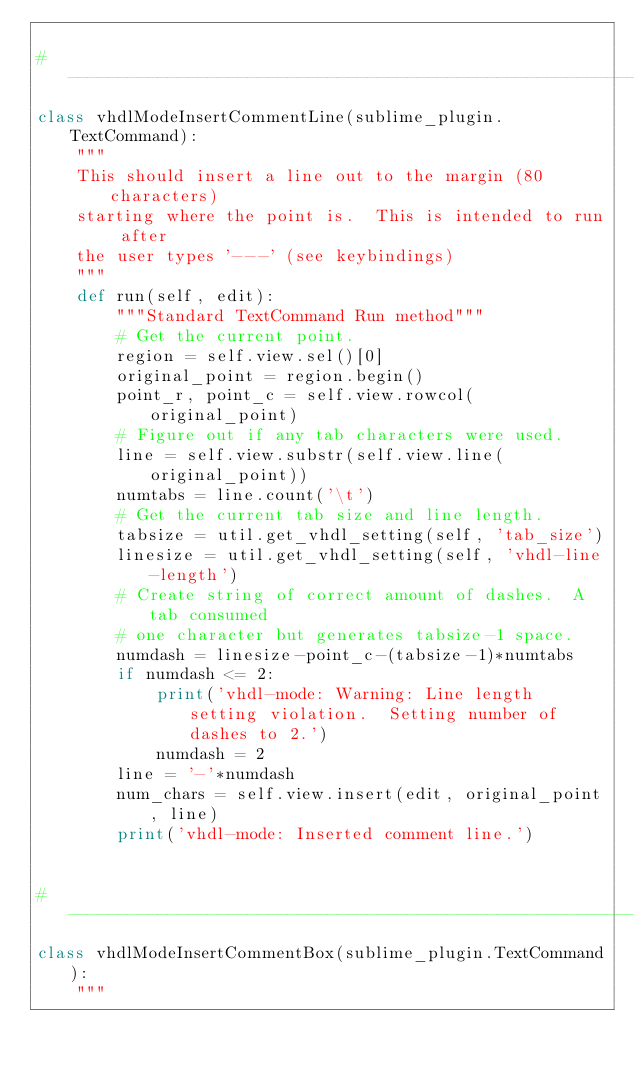<code> <loc_0><loc_0><loc_500><loc_500><_Python_>
#-------------------------------------------------------------------------------
class vhdlModeInsertCommentLine(sublime_plugin.TextCommand):
    """
    This should insert a line out to the margin (80 characters)
    starting where the point is.  This is intended to run after
    the user types '---' (see keybindings)
    """
    def run(self, edit):
        """Standard TextCommand Run method"""
        # Get the current point.
        region = self.view.sel()[0]
        original_point = region.begin()
        point_r, point_c = self.view.rowcol(original_point)
        # Figure out if any tab characters were used.
        line = self.view.substr(self.view.line(original_point))
        numtabs = line.count('\t')
        # Get the current tab size and line length.
        tabsize = util.get_vhdl_setting(self, 'tab_size')
        linesize = util.get_vhdl_setting(self, 'vhdl-line-length')
        # Create string of correct amount of dashes.  A tab consumed
        # one character but generates tabsize-1 space.
        numdash = linesize-point_c-(tabsize-1)*numtabs
        if numdash <= 2:
            print('vhdl-mode: Warning: Line length setting violation.  Setting number of dashes to 2.')
            numdash = 2
        line = '-'*numdash
        num_chars = self.view.insert(edit, original_point, line)
        print('vhdl-mode: Inserted comment line.')


#-------------------------------------------------------------------------------
class vhdlModeInsertCommentBox(sublime_plugin.TextCommand):
    """</code> 